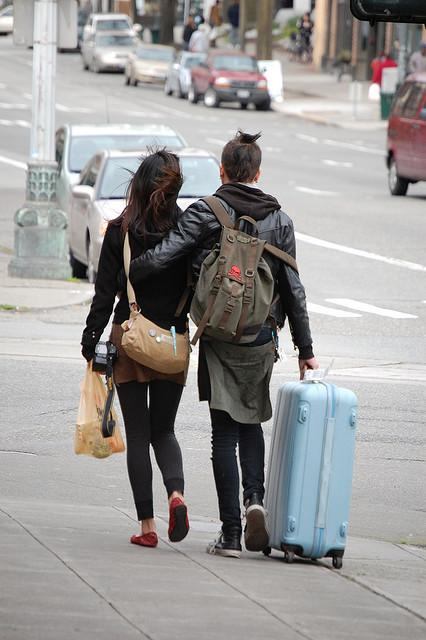What type of parking is available? street 